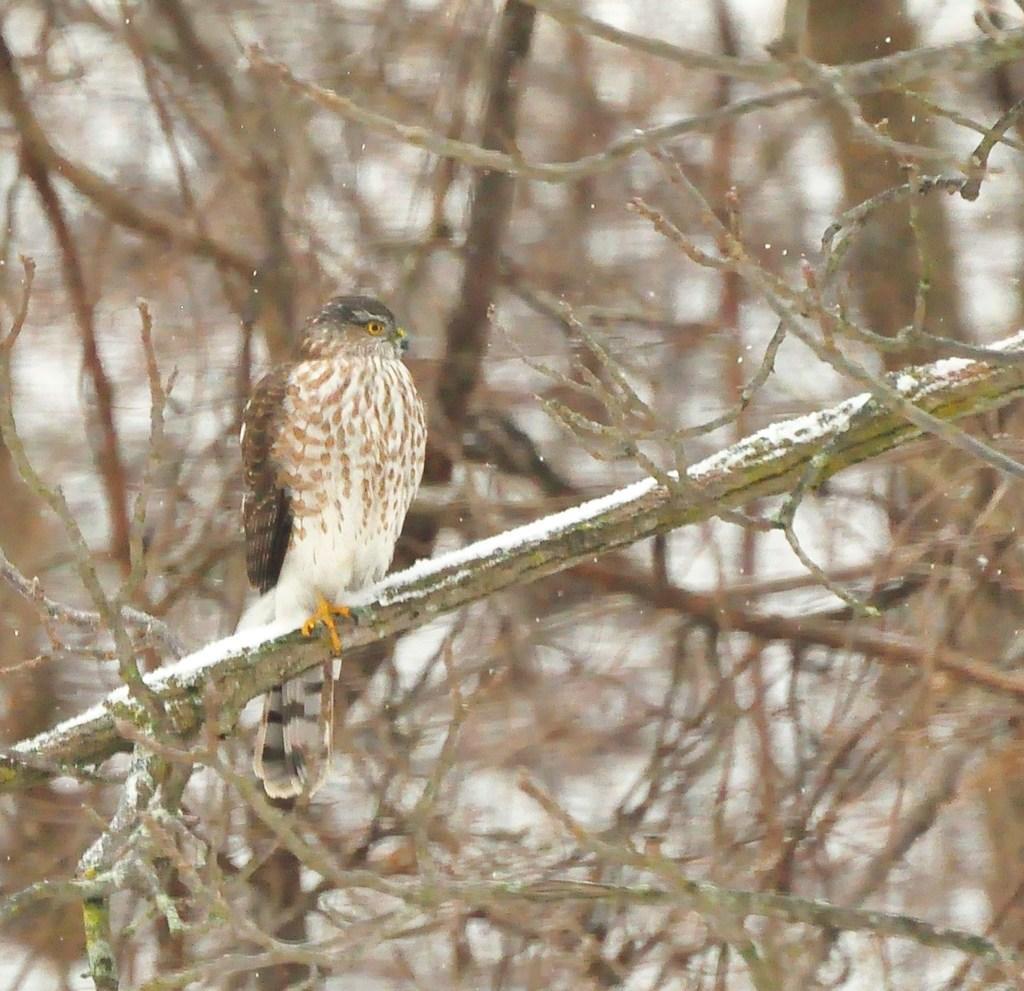In one or two sentences, can you explain what this image depicts? In this image we can see there is a bird on a tree. 